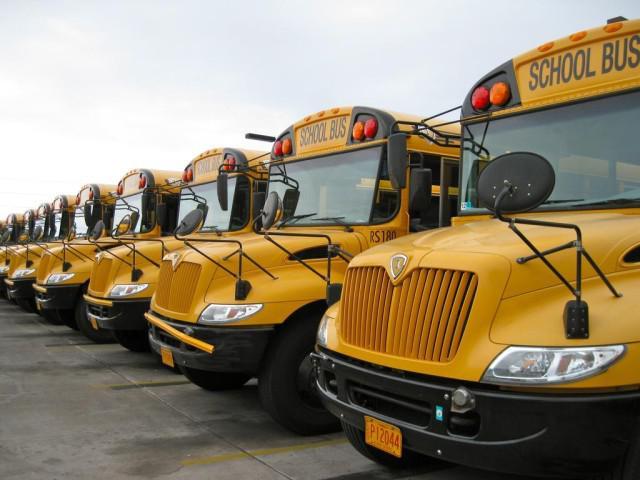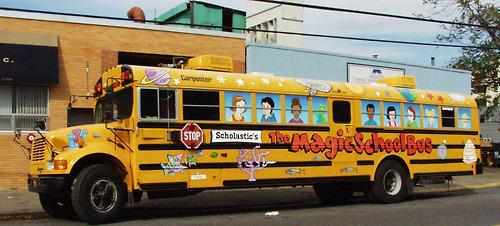The first image is the image on the left, the second image is the image on the right. Evaluate the accuracy of this statement regarding the images: "The photo on the right shows a school bus that has been painted, while the image on the left shows a row of at least five school buses.". Is it true? Answer yes or no. Yes. 